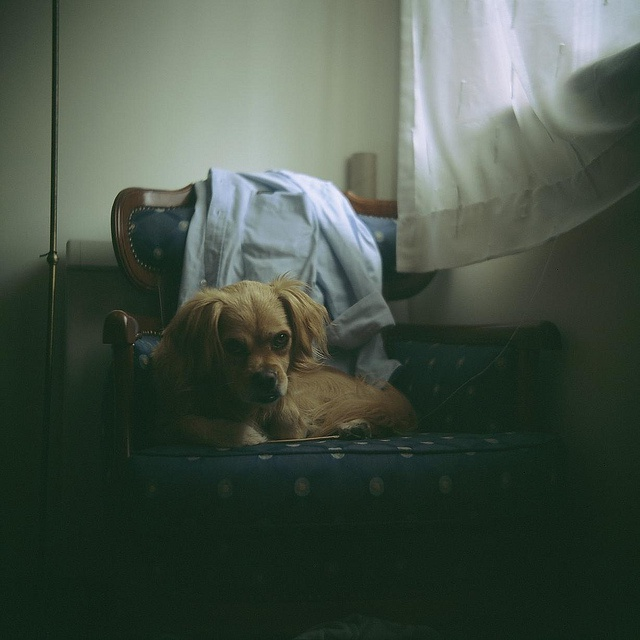Describe the objects in this image and their specific colors. I can see couch in black, gray, and darkgray tones, chair in black, gray, and purple tones, and dog in black, gray, and olive tones in this image. 